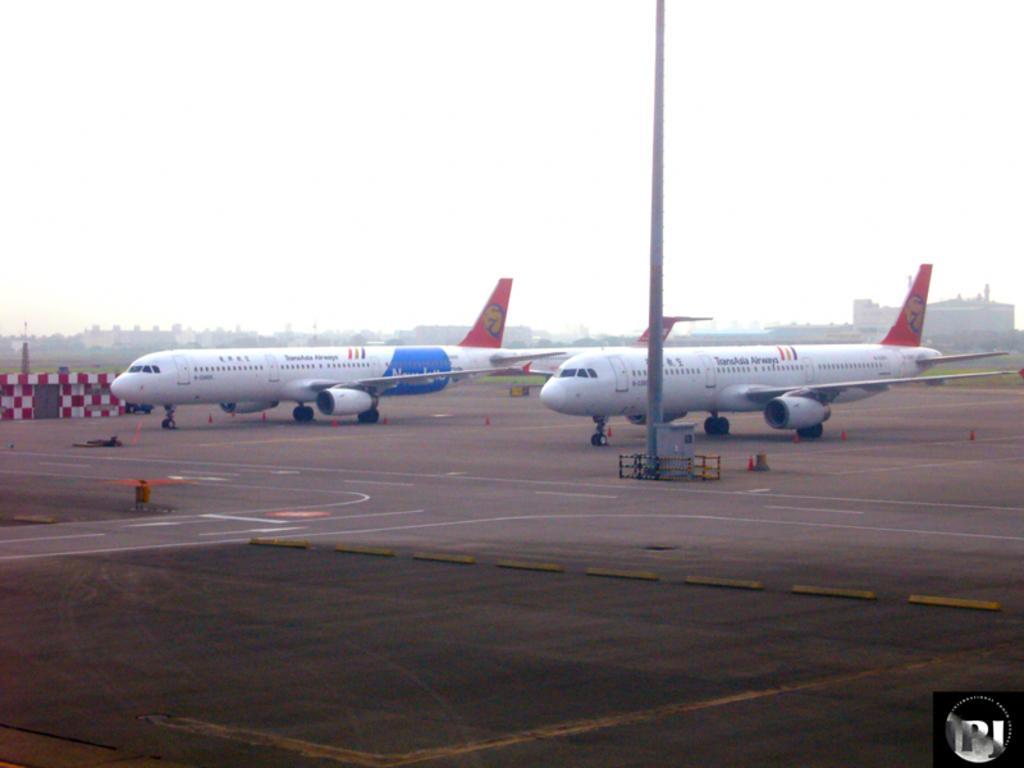How would you summarize this image in a sentence or two? This image is taken outdoors. At the top of the image there is the sky. At the bottom of the image there is a runway. In the background there are a few buildings and there is a ground with grass on it. In the middle of the image there are two airplanes on the runway and there is a pole. There are two objects on the runway. 